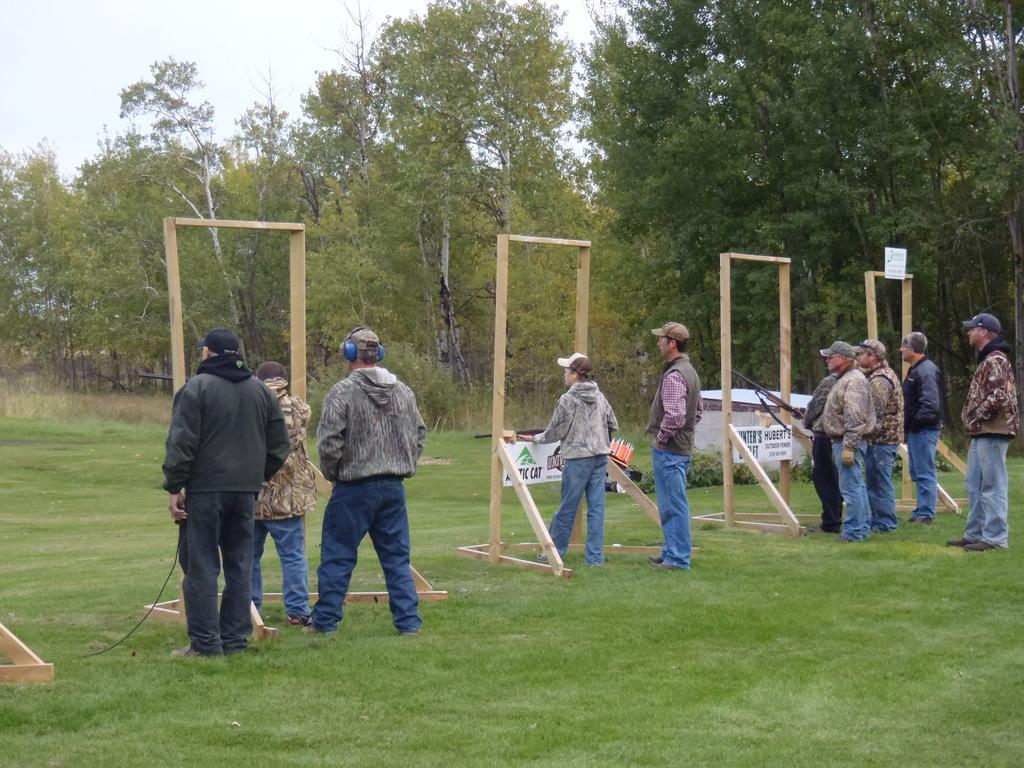What is the surface that the people are standing on in the image? The people are standing on the grass in the image. What object is present in front of the people? There is a wooden stand with a gun in front of the people. What can be seen in the background of the image? Trees and the sky are visible in the background of the image. Can you see the sea in the background of the image? No, there is no sea visible in the background of the image. What type of cap is the person wearing in the image? There is no person wearing a cap in the image. 